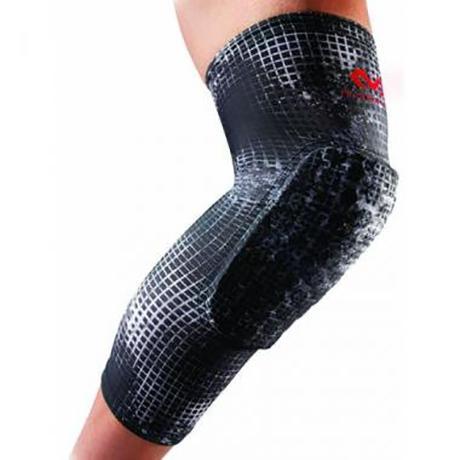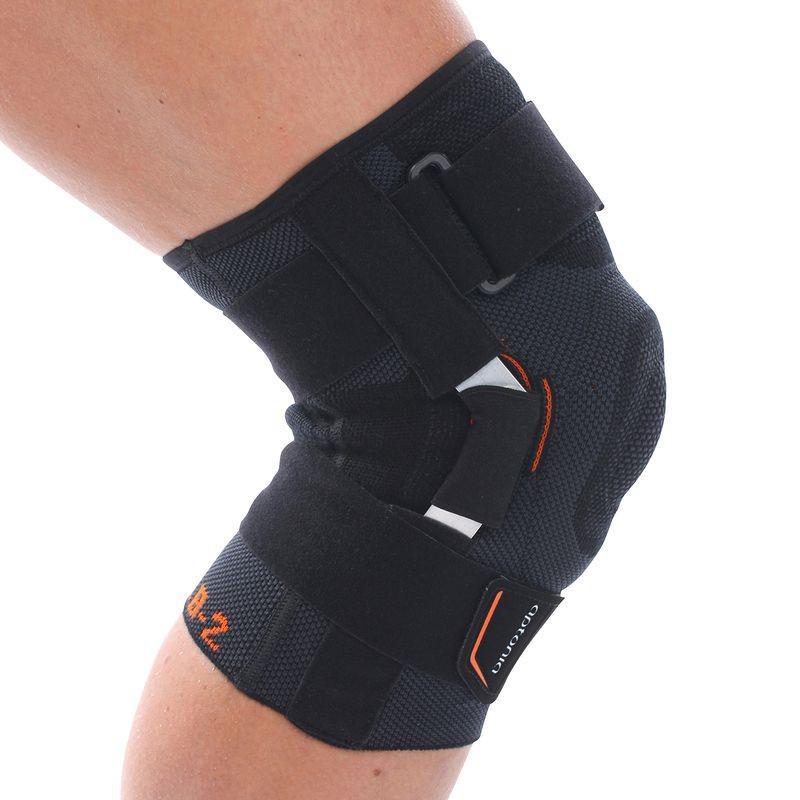The first image is the image on the left, the second image is the image on the right. For the images shown, is this caption "Exactly two kneepads are modeled on human legs, both of the pads black with a logo, but different designs." true? Answer yes or no. Yes. The first image is the image on the left, the second image is the image on the right. Evaluate the accuracy of this statement regarding the images: "There are exactly two knee braces.". Is it true? Answer yes or no. Yes. 